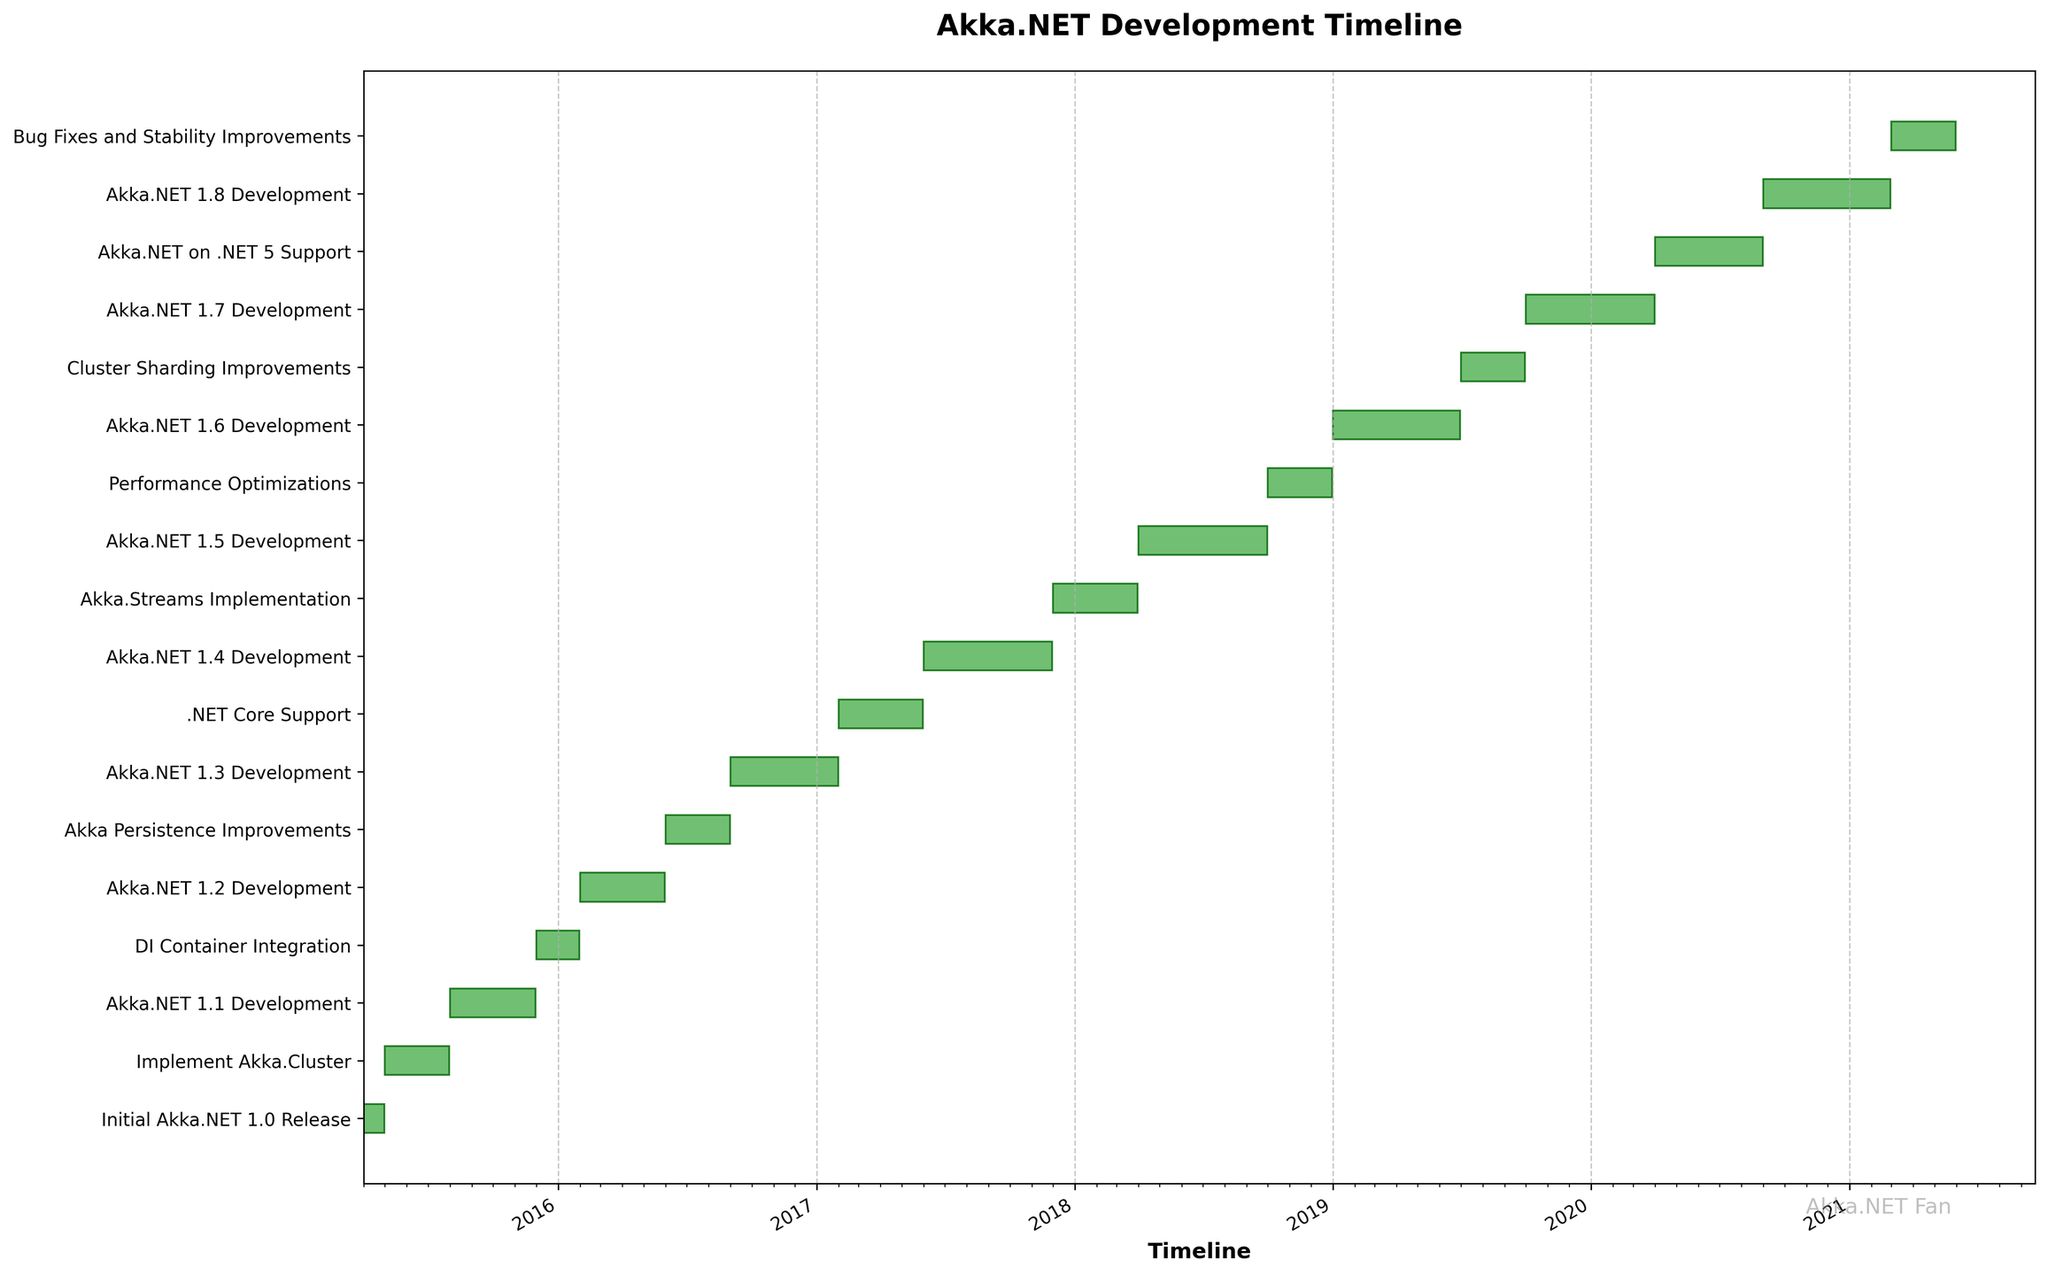What's the title of the chart? The title is located at the top of the chart. It provides an overall description of what the chart represents.
Answer: Akka.NET Development Timeline How many tasks are displayed in the chart? Count the number of horizontal bars representing different tasks. Each bar represents one task.
Answer: 18 Which development phase took the longest duration? Check the horizontal bars to identify the task that is visually the longest. This task represents the duration with the greatest number of days.
Answer: Akka.NET 1.4 Development What are the start and end dates of the Initial Akka.NET 1.0 Release? Look for the "Initial Akka.NET 1.0 Release" task on the y-axis, then refer to its start and end points on the x-axis.
Answer: 2015-04-01 to 2015-04-30 Which version update started immediately after the development of Akka.NET 1.1? Identify the end date of "Akka.NET 1.1 Development" and find the task that starts the next day, or immediately thereafter.
Answer: DI Container Integration Compare the duration of Akka.Persistence Improvements with Bug Fixes and Stability Improvements. Which one is longer and by how many days? Refer to the horizontal bars representing each task. Bug Fixes and Stability Improvements lasts for 92 days, while Akka Persistence Improvements also lasts for 92 days.
Answer: Both have the same duration of 92 days During which year did Akka.NET 1.3 Development start and end, and what was the total number of days for this task? Locate the "Akka.NET 1.3 Development" bar, then identify its start and end dates to determine the year. Calculate the number of days by counting horizontally.
Answer: 2016-09-01 to 2017-01-31; 153 days What major feature was developed after the completion of Akka.NET 1.4 Development? After locating the end of "Akka.NET 1.4 Development," find the next task's bar to see which significant feature it represents.
Answer: Akka.Streams Implementation How long did the support for Akka.NET on .NET 5 take, and when did it start and end? Look for the horizontal bar labeled "Akka.NET on .NET 5 Support." Note its length to know the duration and its corresponding dates on the x-axis.
Answer: 153 days; 2020-04-01 to 2020-08-31 Which task marked the beginning of development activities in 2018? Identify the first task bar starting in the year 2018 based on the x-axis timeline.
Answer: Akka.NET 1.5 Development 